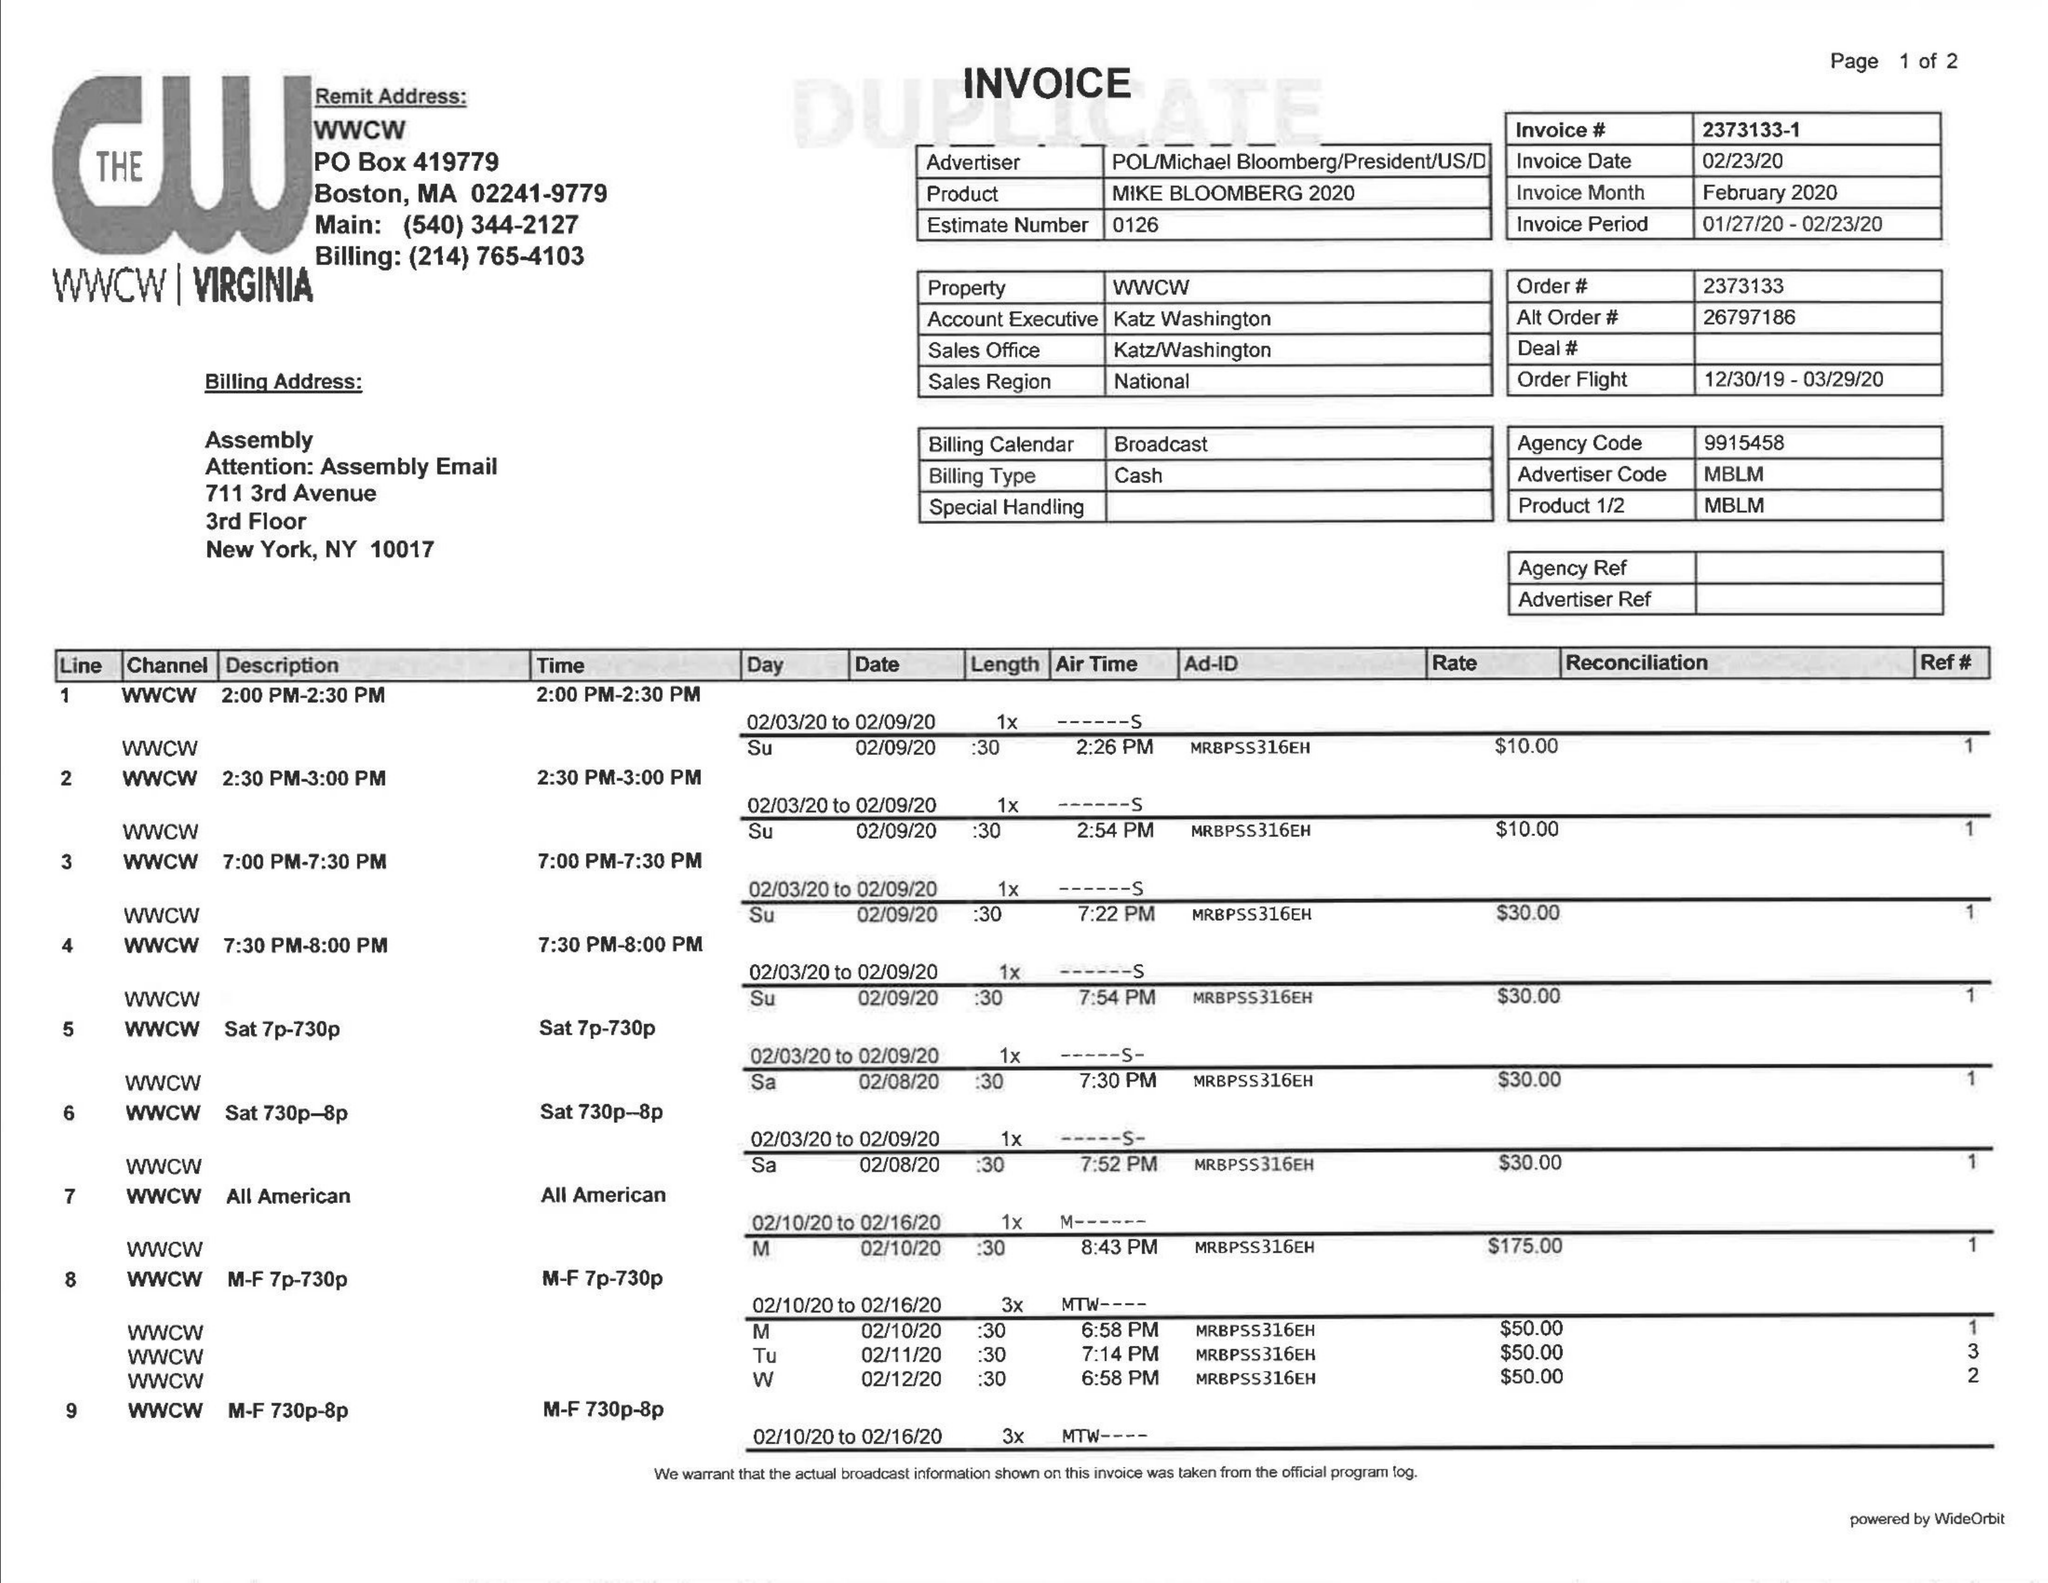What is the value for the flight_from?
Answer the question using a single word or phrase. 12/30/19 